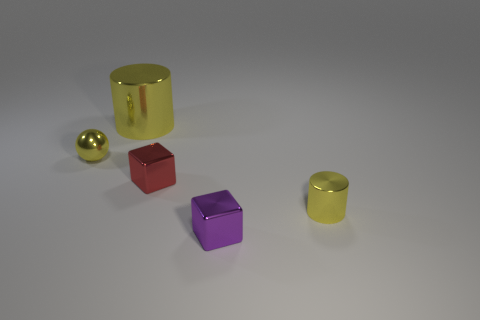Add 1 tiny yellow balls. How many objects exist? 6 Subtract all blocks. How many objects are left? 3 Subtract all green cubes. Subtract all tiny yellow things. How many objects are left? 3 Add 1 tiny purple things. How many tiny purple things are left? 2 Add 5 brown matte balls. How many brown matte balls exist? 5 Subtract 0 yellow cubes. How many objects are left? 5 